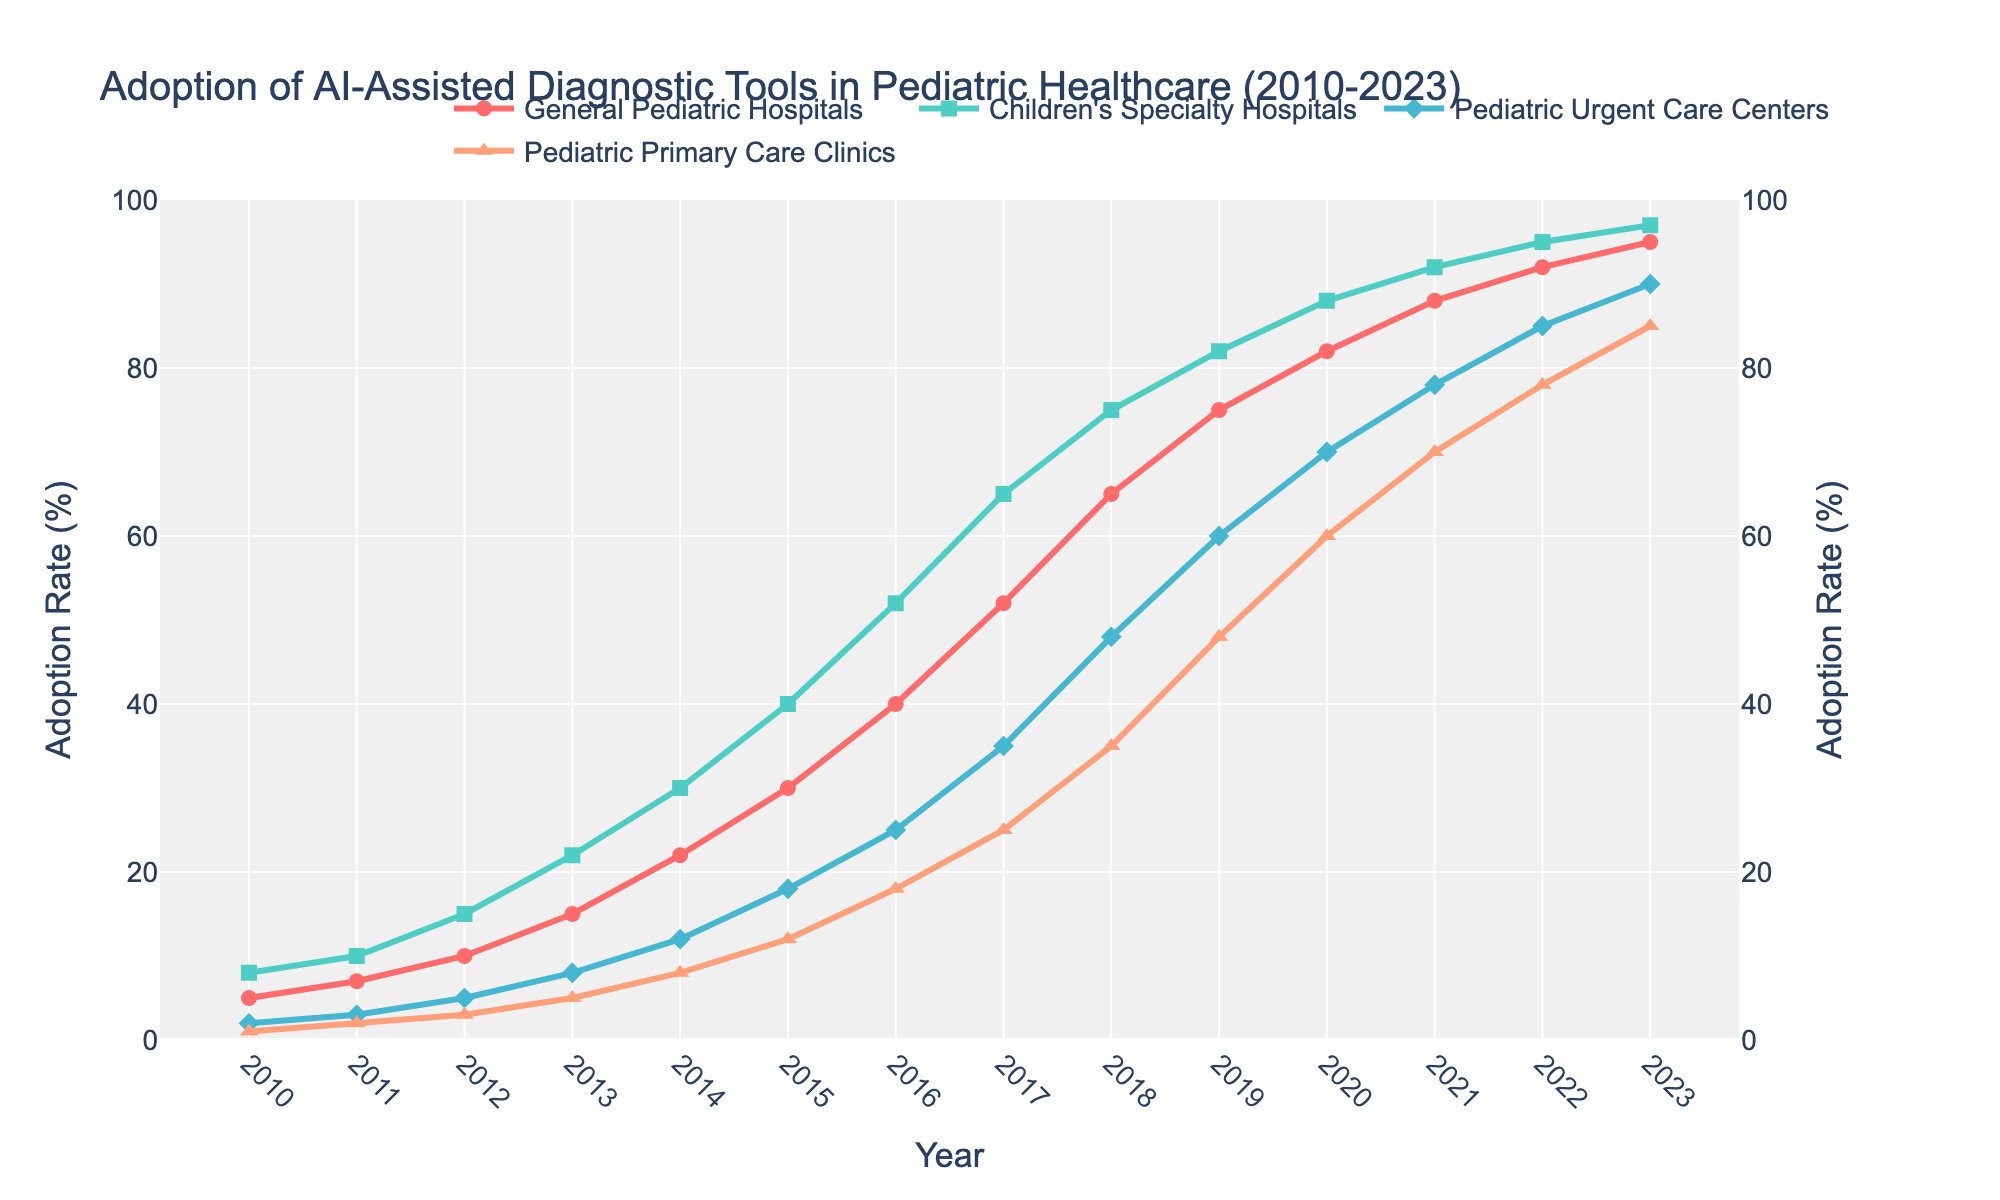Which healthcare facility type has the highest adoption rate of AI-assisted diagnostic tools in 2023? From the figure, the highest adoption rate in 2023 can be identified by finding the point on the graph that reaches the highest value. "Children's Specialty Hospitals" reaches the highest point at 97%.
Answer: Children's Specialty Hospitals How does the adoption rate of AI-assisted diagnostic tools in Pediatric Urgent Care Centers in 2015 compare to General Pediatric Hospitals in the same year? The figure shows that in 2015, Pediatric Urgent Care Centers are represented by a point with an adoption rate of 18%, and General Pediatric Hospitals have an adoption rate of 30%. Comparing these values, General Pediatric Hospitals have a higher adoption rate.
Answer: General Pediatric Hospitals What is the change in adoption rate for Pediatric Primary Care Clinics from 2010 to 2020? To find the change in adoption rate, we subtract the value in 2010 from the value in 2020. Pediatric Primary Care Clinics had 1% in 2010 and 60% in 2020. Thus, the change is 60 - 1 = 59%.
Answer: 59% Between 2012 and 2018, which healthcare facility type showed the steepest increase in adoption rate? Examining the slopes of the lines between 2012 and 2018, General Pediatric Hospitals showed a rise from 10% to 65% (+55%), Children's Specialty Hospitals from 15% to 75% (+60%), Pediatric Urgent Care Centers from 5% to 48% (+43%), and Pediatric Primary Care Clinics from 3% to 35% (+32%). The steepest increase is by Children's Specialty Hospitals.
Answer: Children's Specialty Hospitals What is the average adoption rate of AI-assisted diagnostic tools in General Pediatric Hospitals from 2010 to 2015? We first collect the values for the years: 2010 (5%), 2011 (7%), 2012 (10%), 2013 (15%), 2014 (22%), 2015 (30%). Adding these values gives a total of 89%. Dividing by the number of years (6) gives an average of 89/6 = 14.83%.
Answer: 14.83% In which year did Pediatric Urgent Care Centers reach an adoption rate of 70%? Looking at the line for Pediatric Urgent Care Centers, it reaches 70% in the year 2020.
Answer: 2020 Which healthcare facility type experienced the smallest percentage increase in adoption rate from 2010 to 2023? By calculating the percentage increase for each type, we get: General Pediatric Hospitals: (95-5)/5 * 100 = 1800%, Children's Specialty Hospitals: (97-8)/8 * 100 = 1112.5%, Pediatric Urgent Care Centers: (90-2)/2 * 100 = 4400%, Pediatric Primary Care Clinics: (85-1)/1 * 100 = 8400%. The smallest percentage increase is in Children's Specialty Hospitals.
Answer: Children's Specialty Hospitals What visual differences can be observed in the trends between Pediatric Primary Care Clinics and General Pediatric Hospitals? Visually, the line for Pediatric Primary Care Clinics starts lower and rises gradually, with smaller increments initially but accelerating over time. In contrast, General Pediatric Hospitals start higher and show a consistent, smooth increasing trend.
Answer: Difference in line and growth speed paths What is the sum of the adoption rates in 2015 for all healthcare facility types? The values for 2015 are: General Pediatric Hospitals (30%), Children's Specialty Hospitals (40%), Pediatric Urgent Care Centers (18%), Pediatric Primary Care Clinics (12%). Summing these values, we get 30 + 40 + 18 + 12 = 100%.
Answer: 100% In 2019, which healthcare facility type had an equivalent adoption rate to that of Pediatric Primary Care Clinics in 2023? From the figure, in 2019, Pediatric Urgent Care Centers had an adoption rate of 60%. This matches the Pediatric Primary Care Clinics' adoption rate in 2023.
Answer: Pediatric Urgent Care Centers 